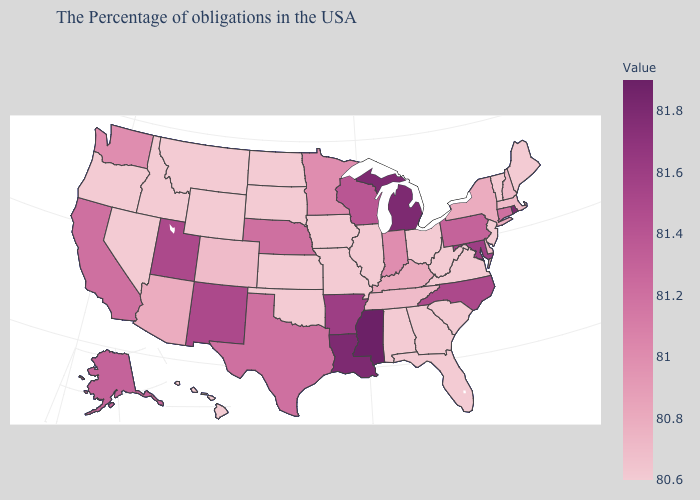Does Nevada have the lowest value in the USA?
Write a very short answer. Yes. Is the legend a continuous bar?
Give a very brief answer. Yes. Which states have the lowest value in the West?
Be succinct. Wyoming, Montana, Idaho, Nevada, Oregon, Hawaii. Does Massachusetts have the lowest value in the USA?
Quick response, please. No. Which states have the highest value in the USA?
Write a very short answer. Mississippi. Does the map have missing data?
Write a very short answer. No. Which states have the lowest value in the USA?
Be succinct. Maine, Vermont, New Jersey, Virginia, South Carolina, West Virginia, Ohio, Florida, Georgia, Alabama, Illinois, Missouri, Iowa, Kansas, Oklahoma, South Dakota, North Dakota, Wyoming, Montana, Idaho, Nevada, Oregon, Hawaii. 